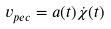<formula> <loc_0><loc_0><loc_500><loc_500>v _ { p e c } = a ( t ) \dot { \chi } ( t )</formula> 